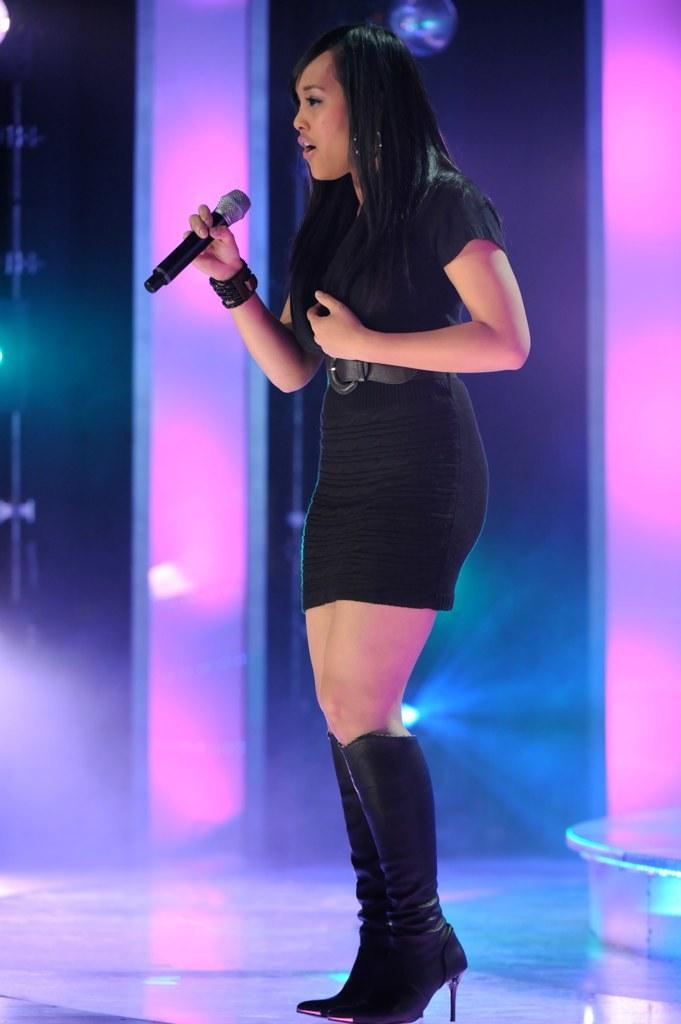Who is the main subject in the image? There is a woman in the image. Where is the woman located in the image? The woman is standing on a stage. What is the woman holding in her hand? The woman is holding a microphone in her hand. What is the woman doing in the image? The woman is singing. What type of poison is the woman using to enhance her singing in the image? There is no poison present in the image, and the woman is not using any substance to enhance her singing. 